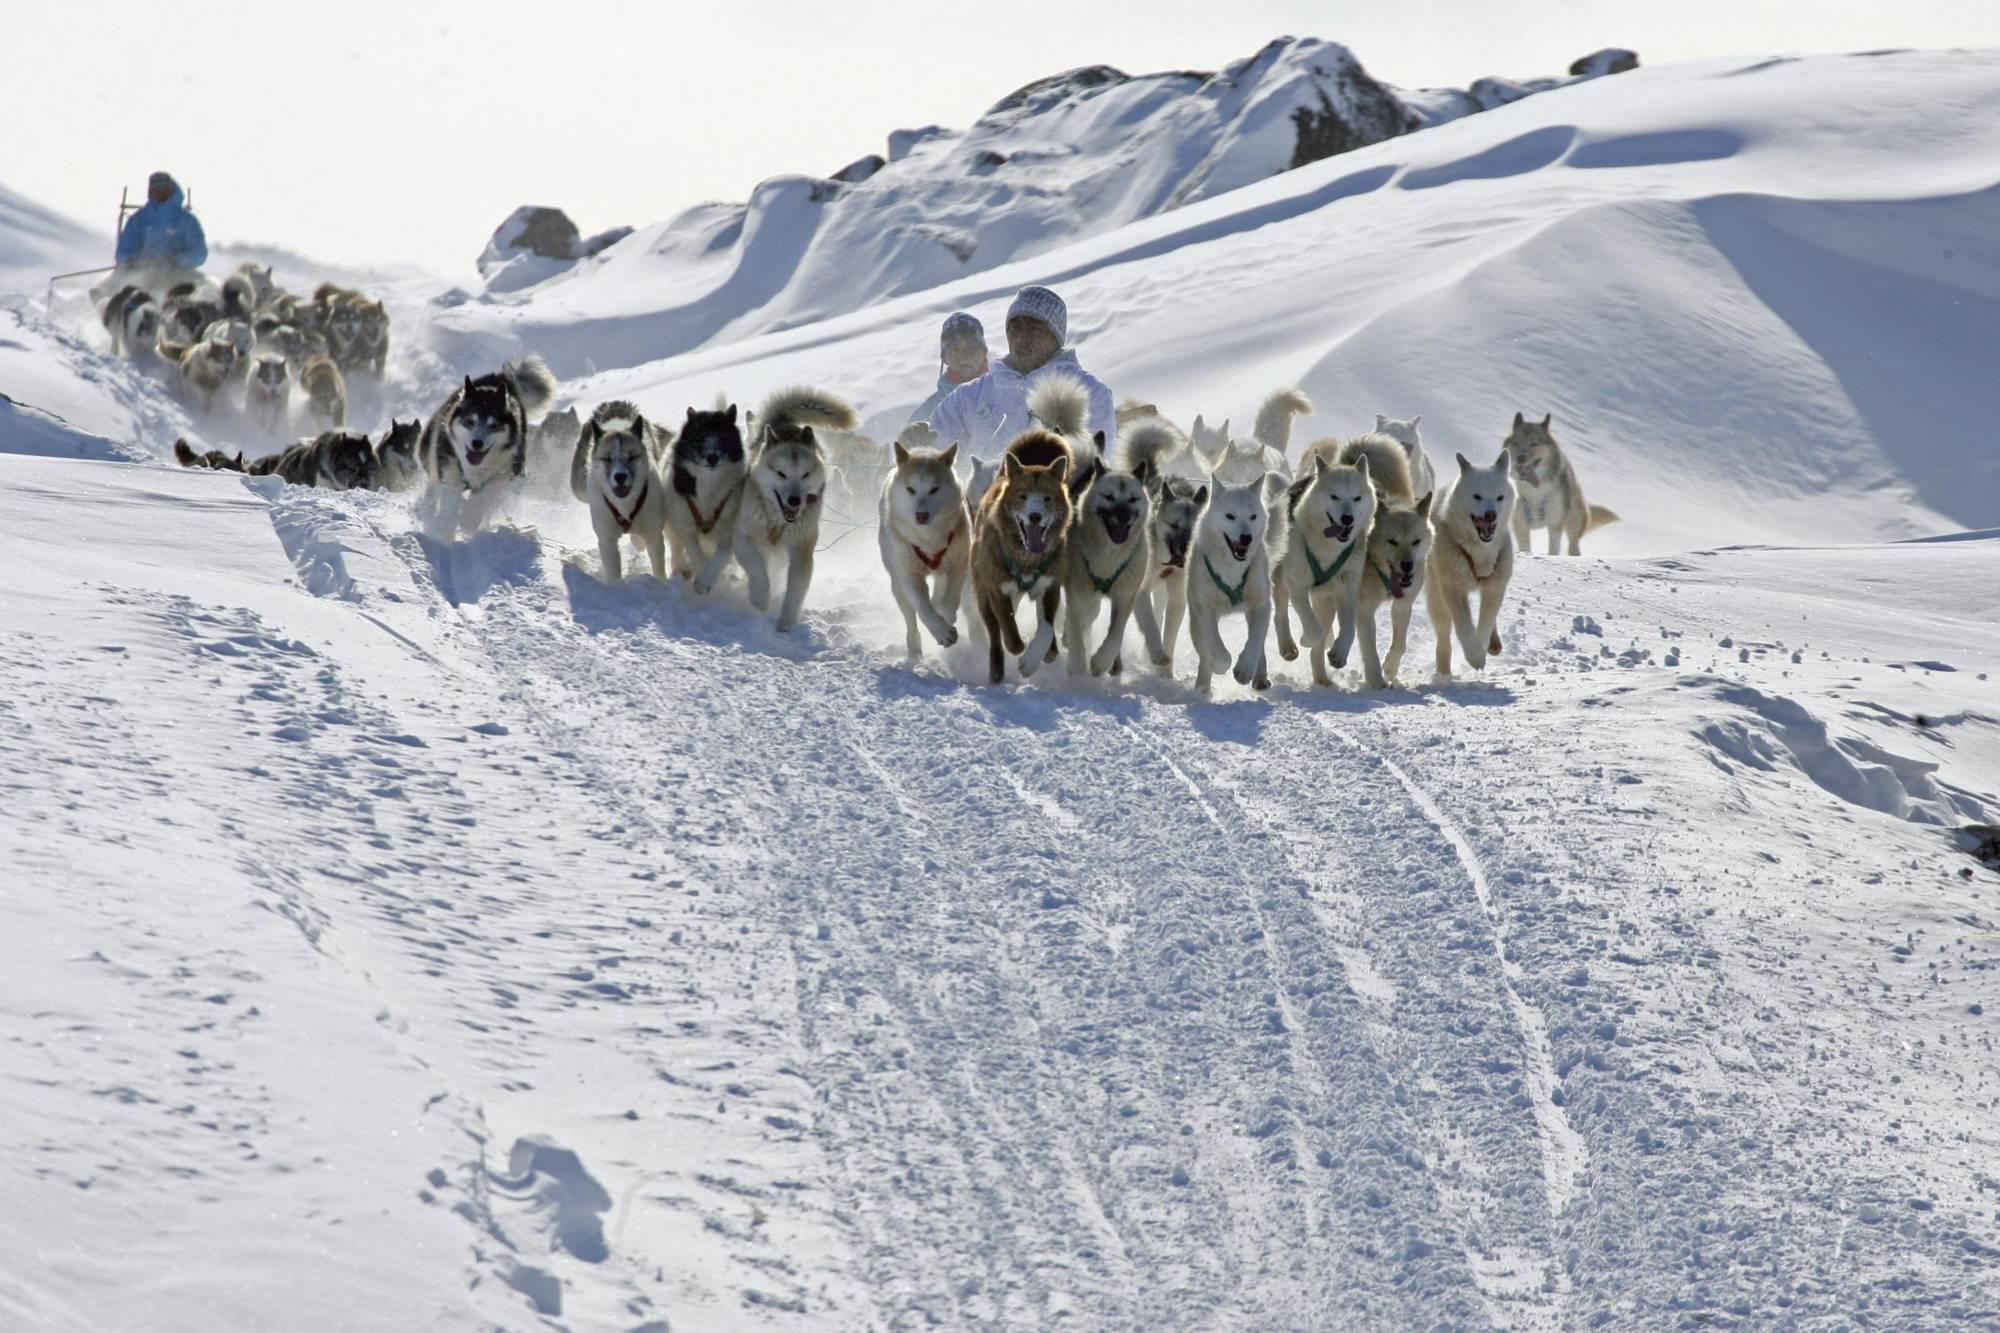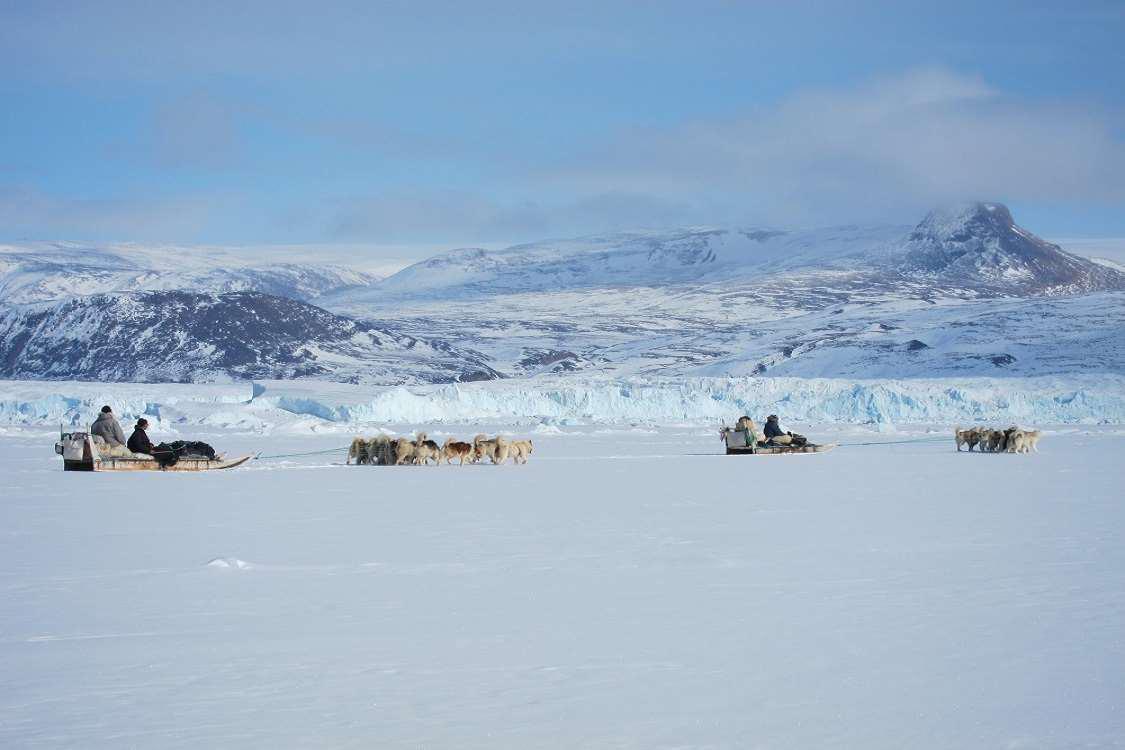The first image is the image on the left, the second image is the image on the right. Evaluate the accuracy of this statement regarding the images: "There are trees visible in both images.". Is it true? Answer yes or no. No. The first image is the image on the left, the second image is the image on the right. Examine the images to the left and right. Is the description "One image shows at least one sled dog team moving horizontally rightward, and the other image shows at least one dog team moving forward at some angle." accurate? Answer yes or no. Yes. 